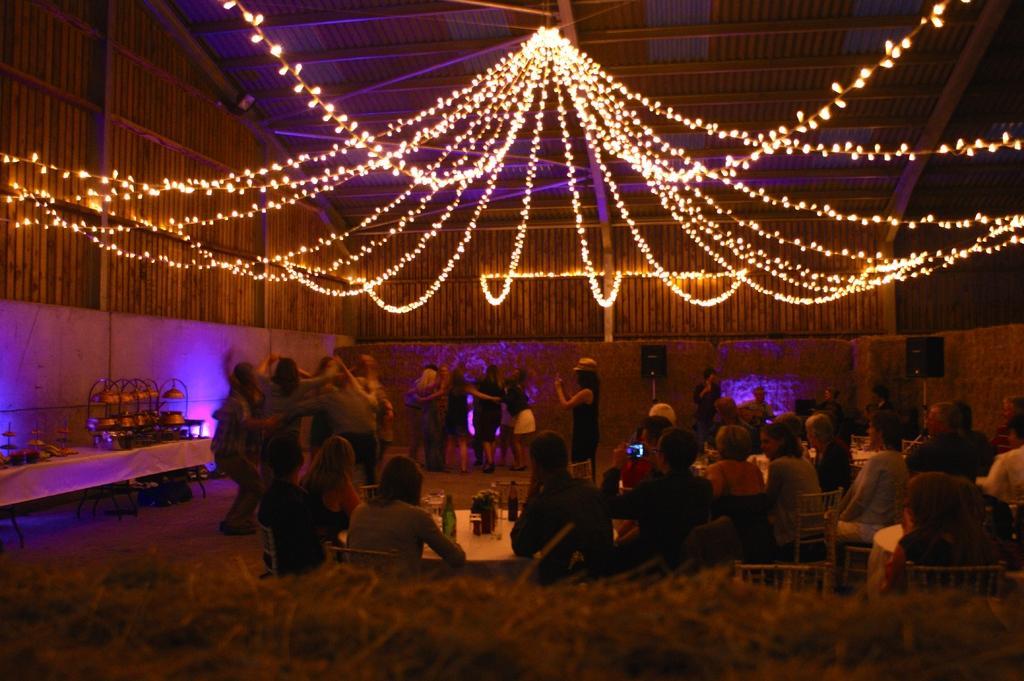Please provide a concise description of this image. In this picture I can see some people are sitting on chairs. Some people are dancing. Some people are playing music. I can see speakers. I can see lights at the top. I can see tables on left hand side. 